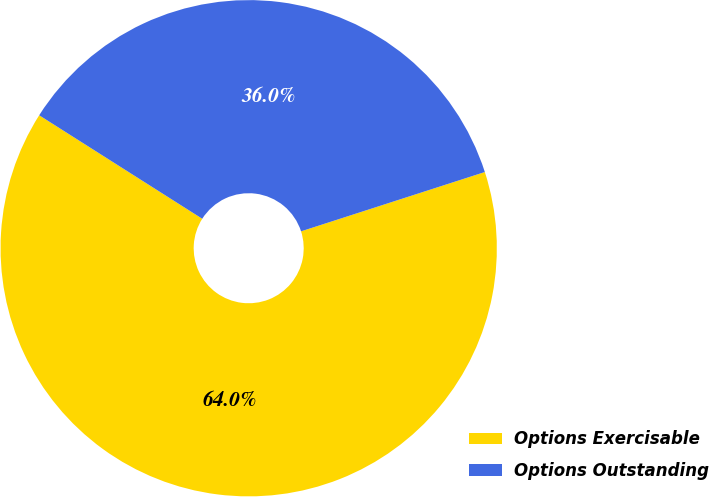<chart> <loc_0><loc_0><loc_500><loc_500><pie_chart><fcel>Options Exercisable<fcel>Options Outstanding<nl><fcel>63.97%<fcel>36.03%<nl></chart> 